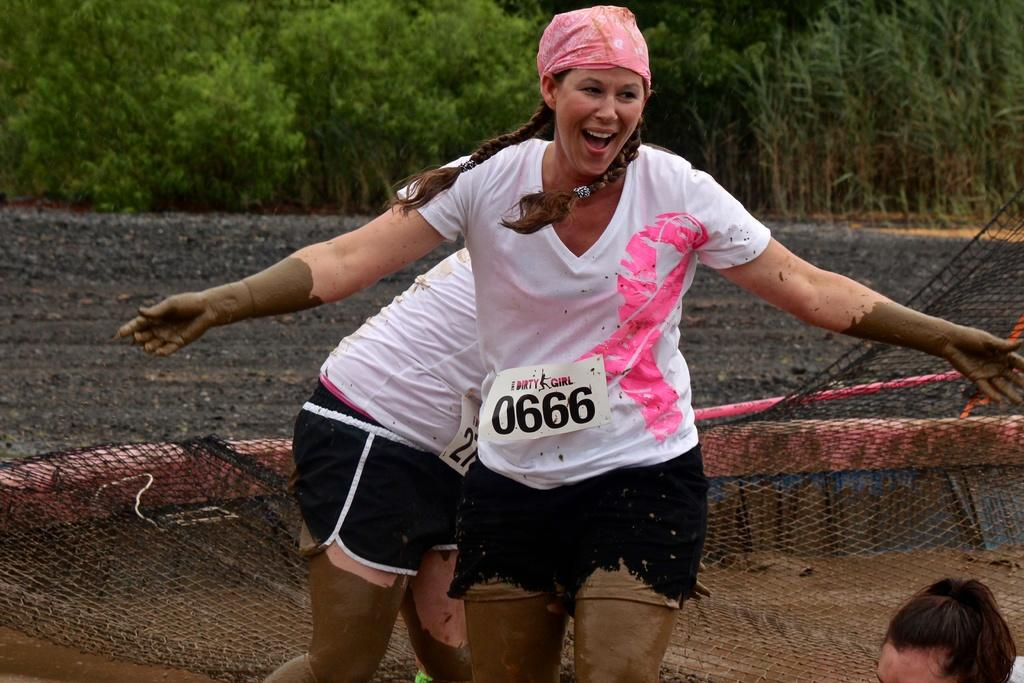Provide a one-sentence caption for the provided image. Two mud run competitors are labeled with numbers, one of them sporting 0666. 